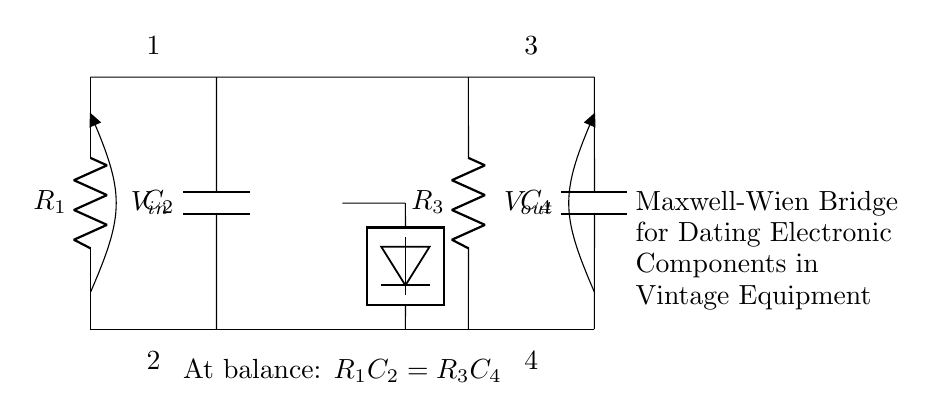What is the voltage source in this circuit? The voltage source is labeled as Vin, which is the input voltage supplied across the bridge. It is shown above the leftmost point of the circuit.
Answer: Vin What are the two types of components present in the Maxwell-Wien Bridge? The circuit includes resistors and capacitors, specifically labeled as R1, R3 (for resistors) and C2, C4 (for capacitors). They are the key components to balance the bridge.
Answer: Resistors and capacitors What is the relation at balance for this bridge? The relation at balance is expressed as R1C2 = R3C4. This equation indicates the condition under which the bridge is balanced and there is no current through the detector.
Answer: R1C2 = R3C4 How many components are connected in this Maxwell-Wien Bridge? There are four main components: two resistors (R1 and R3) and two capacitors (C2 and C4). Their arrangement forms the bridge circuit to test components.
Answer: Four What is the role of the detector in this circuit? The detector measures the null condition, indicating the point of balance in the bridge circuit. It helps identify when no current flows through it, signaling a balanced state.
Answer: Measure balance What would happen if the bridge is not balanced? If the bridge is not balanced, there will be a net current through the detector, leading to a reading on the measurement device, indicating that the resistance and capacitance values are not equal.
Answer: Net current through detector 